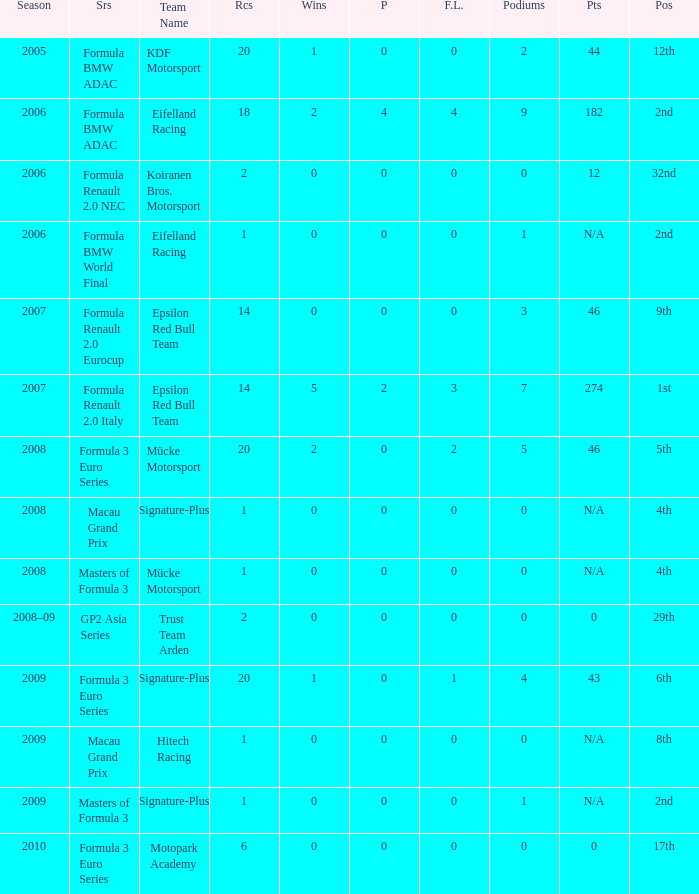What is the race in the 8th position? 1.0. 